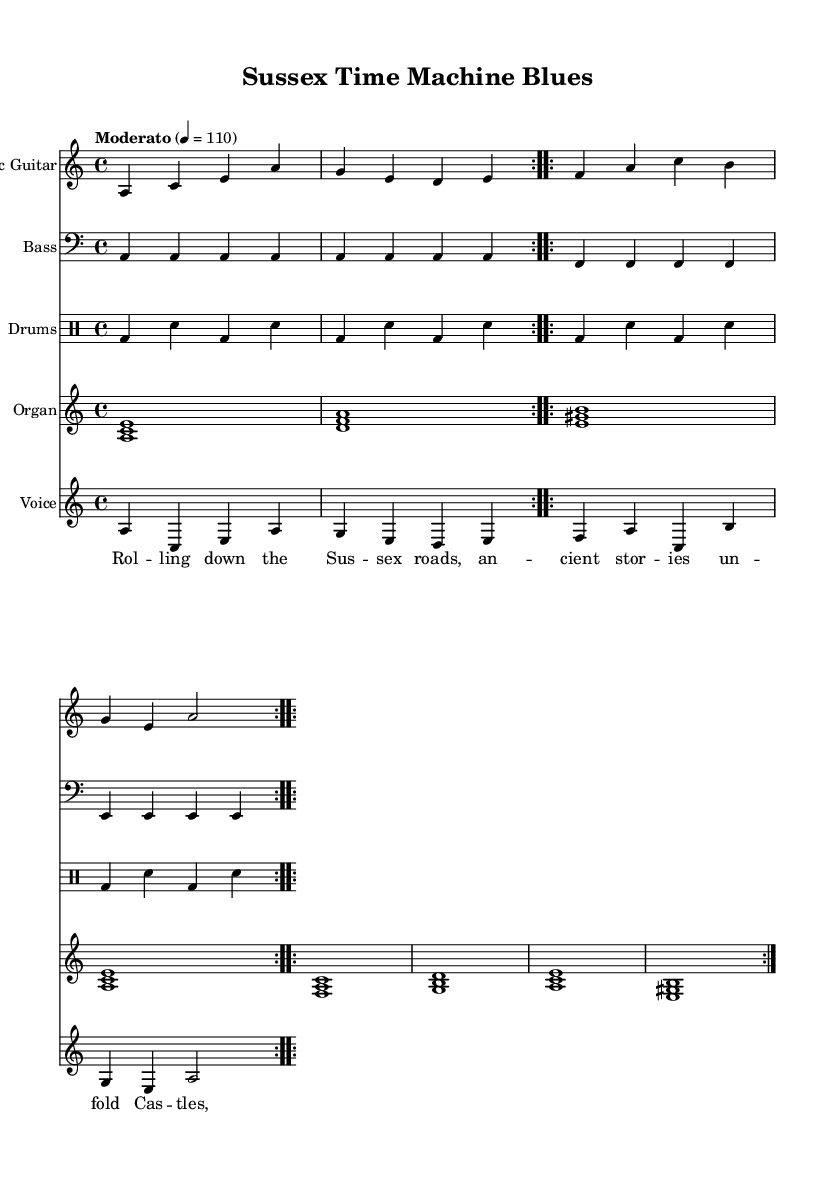What is the key signature of this music? The key signature is A minor, which indicates that there are no sharps or flats. The absence of any accidentals on the staff confirms this.
Answer: A minor What is the time signature of the piece? The time signature is 4/4, which means there are four beats per measure and a quarter note receives one beat. This is clearly indicated at the beginning of the score.
Answer: 4/4 What is the tempo marking provided? The tempo marking is "Moderato," which indicates a moderate speed for the music. It can also be seen associated with the beats-per-minute marking of 110, providing a precise indication of the intended pace.
Answer: Moderato How many measures are in the verse part? The verse part consists of eight measures. This can be tallied by counting each segment of music for the electric guitar that repeats and aligns with the lyrics for the verse.
Answer: Eight measures What instruments are featured in this Electric Blues score? The featured instruments in this score are Electric Guitar, Bass, Drums, and Organ, each clearly labeled within their respective staves at the beginning of the score.
Answer: Electric Guitar, Bass, Drums, Organ What is the main theme reflected in the lyrics of this song? The main theme revolves around traveling and exploring historical sites in Sussex, capturing the spirit of the region's ancient stories, as evident from the lyrics explicitly mentioning castles, ruins, and secrets.
Answer: Exploring historical sites How many times does the chorus repeat in the sheet music? The chorus repeats two times in the sheet music, as indicated with the use of "repeat volta" above both the verse and the chorus sections, showing that each part is meant to be played twice.
Answer: Two times 